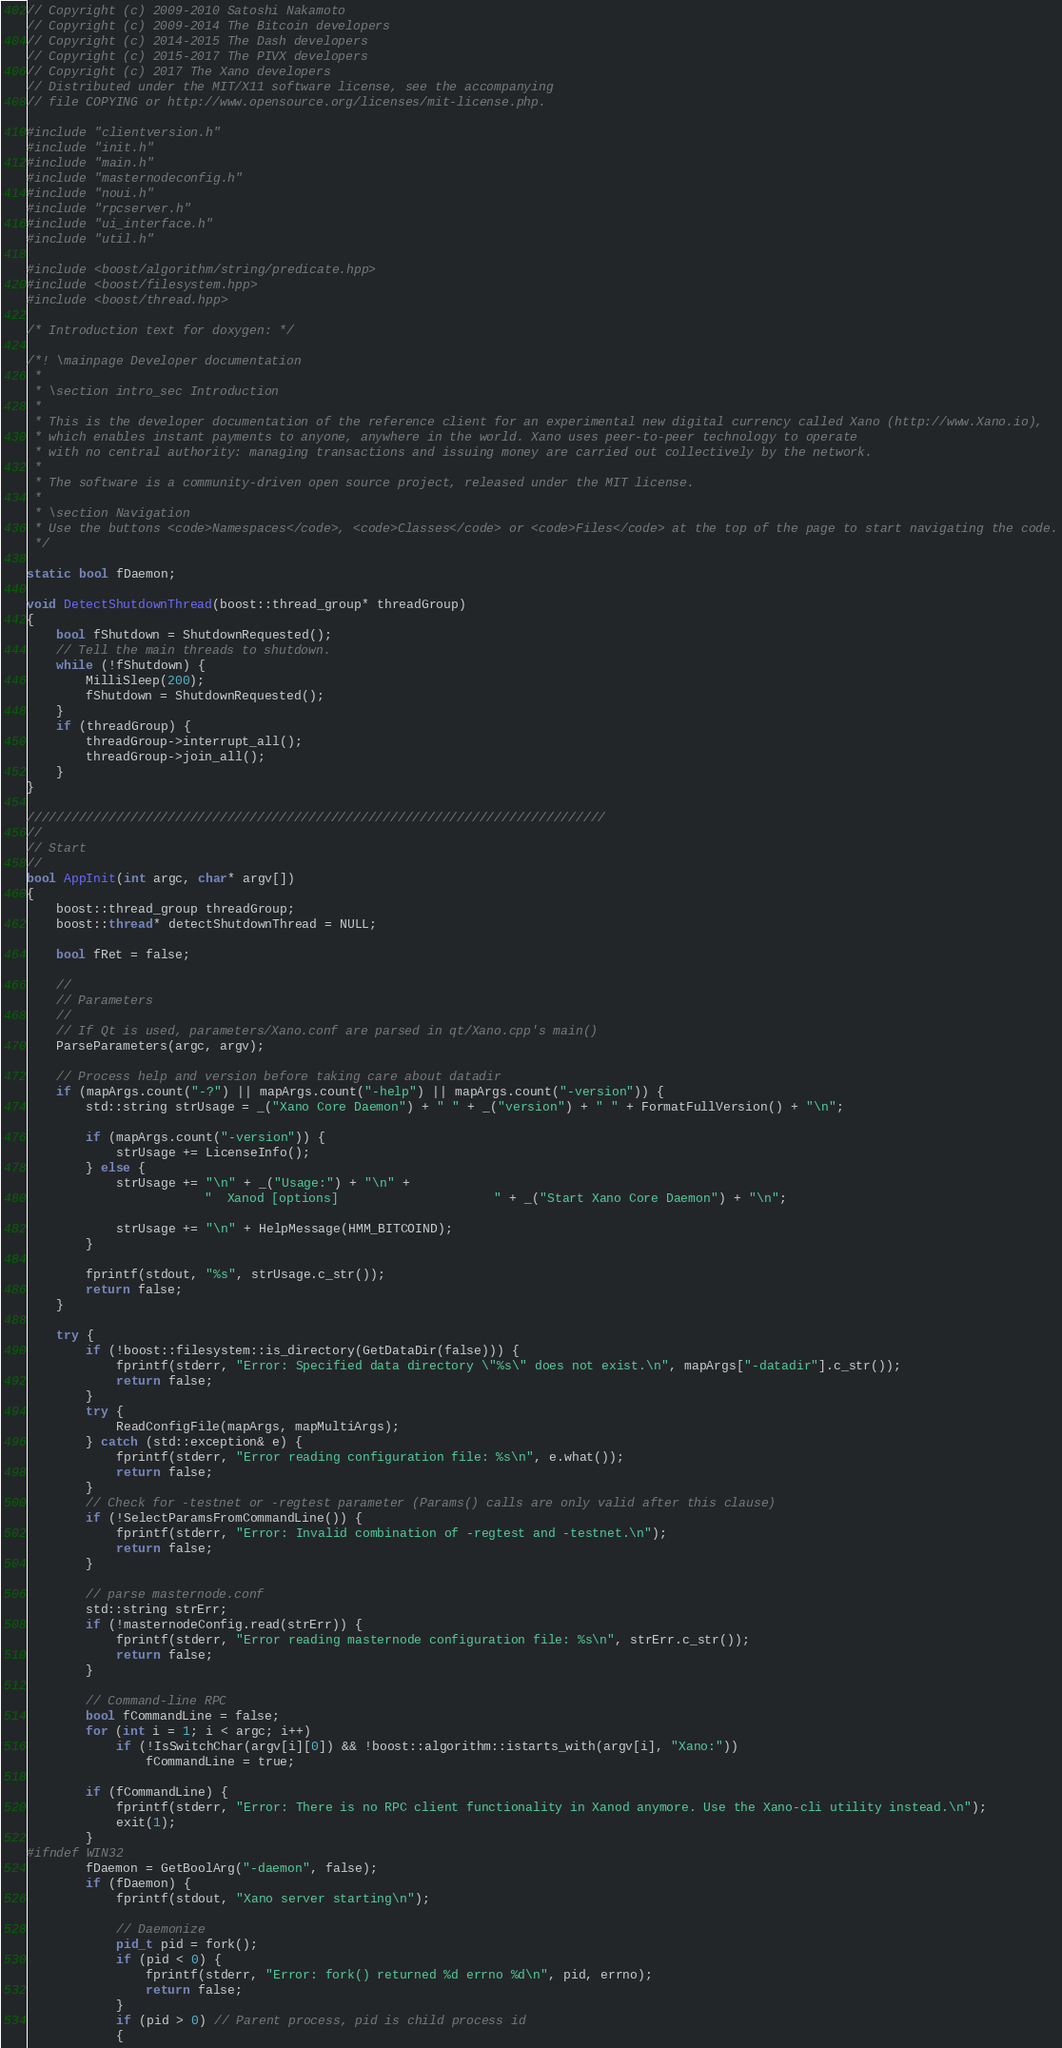<code> <loc_0><loc_0><loc_500><loc_500><_C++_>// Copyright (c) 2009-2010 Satoshi Nakamoto
// Copyright (c) 2009-2014 The Bitcoin developers
// Copyright (c) 2014-2015 The Dash developers
// Copyright (c) 2015-2017 The PIVX developers
// Copyright (c) 2017 The Xano developers
// Distributed under the MIT/X11 software license, see the accompanying
// file COPYING or http://www.opensource.org/licenses/mit-license.php.

#include "clientversion.h"
#include "init.h"
#include "main.h"
#include "masternodeconfig.h"
#include "noui.h"
#include "rpcserver.h"
#include "ui_interface.h"
#include "util.h"

#include <boost/algorithm/string/predicate.hpp>
#include <boost/filesystem.hpp>
#include <boost/thread.hpp>

/* Introduction text for doxygen: */

/*! \mainpage Developer documentation
 *
 * \section intro_sec Introduction
 *
 * This is the developer documentation of the reference client for an experimental new digital currency called Xano (http://www.Xano.io),
 * which enables instant payments to anyone, anywhere in the world. Xano uses peer-to-peer technology to operate
 * with no central authority: managing transactions and issuing money are carried out collectively by the network.
 *
 * The software is a community-driven open source project, released under the MIT license.
 *
 * \section Navigation
 * Use the buttons <code>Namespaces</code>, <code>Classes</code> or <code>Files</code> at the top of the page to start navigating the code.
 */

static bool fDaemon;

void DetectShutdownThread(boost::thread_group* threadGroup)
{
    bool fShutdown = ShutdownRequested();
    // Tell the main threads to shutdown.
    while (!fShutdown) {
        MilliSleep(200);
        fShutdown = ShutdownRequested();
    }
    if (threadGroup) {
        threadGroup->interrupt_all();
        threadGroup->join_all();
    }
}

//////////////////////////////////////////////////////////////////////////////
//
// Start
//
bool AppInit(int argc, char* argv[])
{
    boost::thread_group threadGroup;
    boost::thread* detectShutdownThread = NULL;

    bool fRet = false;

    //
    // Parameters
    //
    // If Qt is used, parameters/Xano.conf are parsed in qt/Xano.cpp's main()
    ParseParameters(argc, argv);

    // Process help and version before taking care about datadir
    if (mapArgs.count("-?") || mapArgs.count("-help") || mapArgs.count("-version")) {
        std::string strUsage = _("Xano Core Daemon") + " " + _("version") + " " + FormatFullVersion() + "\n";

        if (mapArgs.count("-version")) {
            strUsage += LicenseInfo();
        } else {
            strUsage += "\n" + _("Usage:") + "\n" +
                        "  Xanod [options]                     " + _("Start Xano Core Daemon") + "\n";

            strUsage += "\n" + HelpMessage(HMM_BITCOIND);
        }

        fprintf(stdout, "%s", strUsage.c_str());
        return false;
    }

    try {
        if (!boost::filesystem::is_directory(GetDataDir(false))) {
            fprintf(stderr, "Error: Specified data directory \"%s\" does not exist.\n", mapArgs["-datadir"].c_str());
            return false;
        }
        try {
            ReadConfigFile(mapArgs, mapMultiArgs);
        } catch (std::exception& e) {
            fprintf(stderr, "Error reading configuration file: %s\n", e.what());
            return false;
        }
        // Check for -testnet or -regtest parameter (Params() calls are only valid after this clause)
        if (!SelectParamsFromCommandLine()) {
            fprintf(stderr, "Error: Invalid combination of -regtest and -testnet.\n");
            return false;
        }

        // parse masternode.conf
        std::string strErr;
        if (!masternodeConfig.read(strErr)) {
            fprintf(stderr, "Error reading masternode configuration file: %s\n", strErr.c_str());
            return false;
        }

        // Command-line RPC
        bool fCommandLine = false;
        for (int i = 1; i < argc; i++)
            if (!IsSwitchChar(argv[i][0]) && !boost::algorithm::istarts_with(argv[i], "Xano:"))
                fCommandLine = true;

        if (fCommandLine) {
            fprintf(stderr, "Error: There is no RPC client functionality in Xanod anymore. Use the Xano-cli utility instead.\n");
            exit(1);
        }
#ifndef WIN32
        fDaemon = GetBoolArg("-daemon", false);
        if (fDaemon) {
            fprintf(stdout, "Xano server starting\n");

            // Daemonize
            pid_t pid = fork();
            if (pid < 0) {
                fprintf(stderr, "Error: fork() returned %d errno %d\n", pid, errno);
                return false;
            }
            if (pid > 0) // Parent process, pid is child process id
            {</code> 